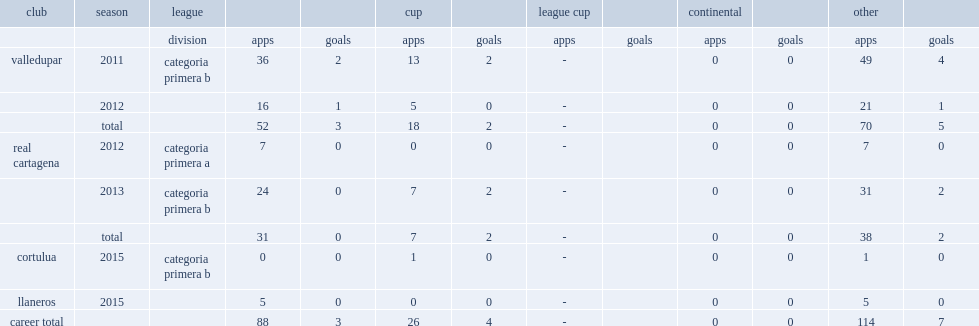Which club did ojeda join in 2011, making his debut in categoria primera b? Valledupar. 